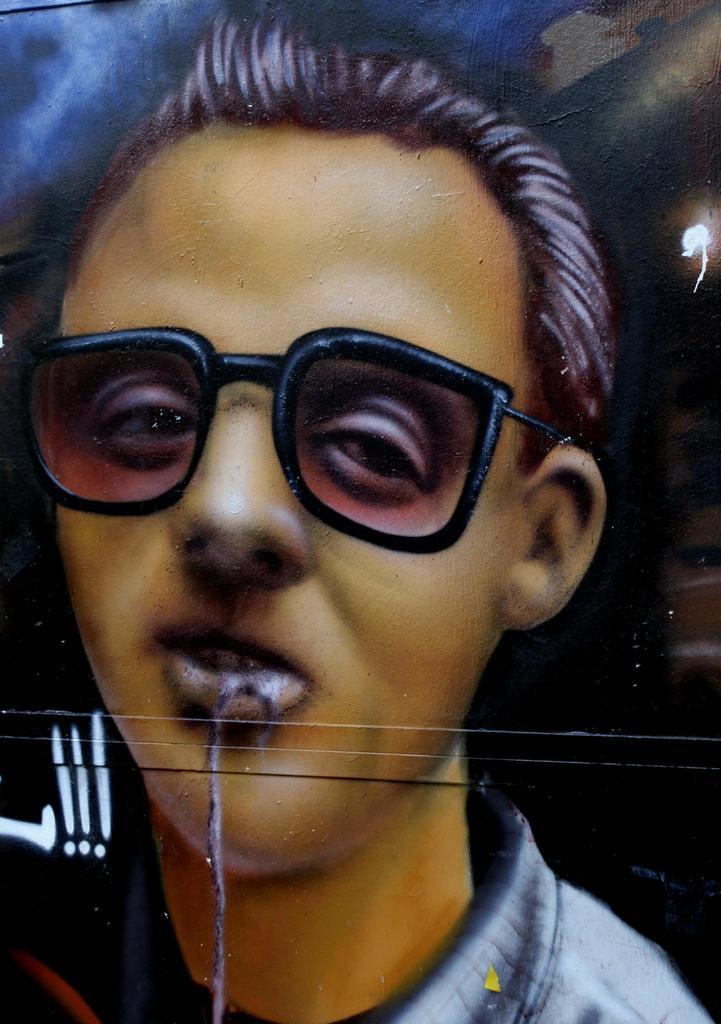Can you describe this image briefly? In this image I can see depiction of a man wearing shades. I can also see blue and black colour in background. 